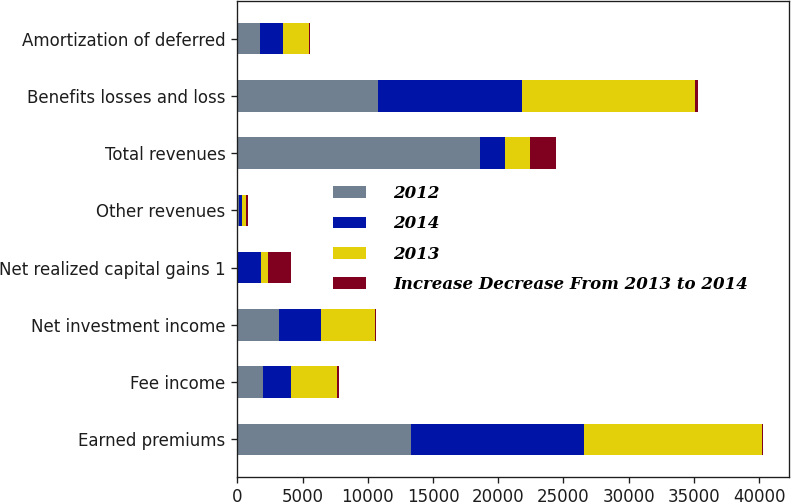Convert chart. <chart><loc_0><loc_0><loc_500><loc_500><stacked_bar_chart><ecel><fcel>Earned premiums<fcel>Fee income<fcel>Net investment income<fcel>Net realized capital gains 1<fcel>Other revenues<fcel>Total revenues<fcel>Benefits losses and loss<fcel>Amortization of deferred<nl><fcel>2012<fcel>13336<fcel>1996<fcel>3154<fcel>16<fcel>112<fcel>18614<fcel>10805<fcel>1729<nl><fcel>2014<fcel>13231<fcel>2105<fcel>3264<fcel>1798<fcel>275<fcel>1894<fcel>11048<fcel>1794<nl><fcel>2013<fcel>13637<fcel>3567<fcel>4127<fcel>497<fcel>258<fcel>1894<fcel>13195<fcel>1990<nl><fcel>Increase Decrease From 2013 to 2014<fcel>105<fcel>109<fcel>110<fcel>1782<fcel>163<fcel>2059<fcel>243<fcel>65<nl></chart> 